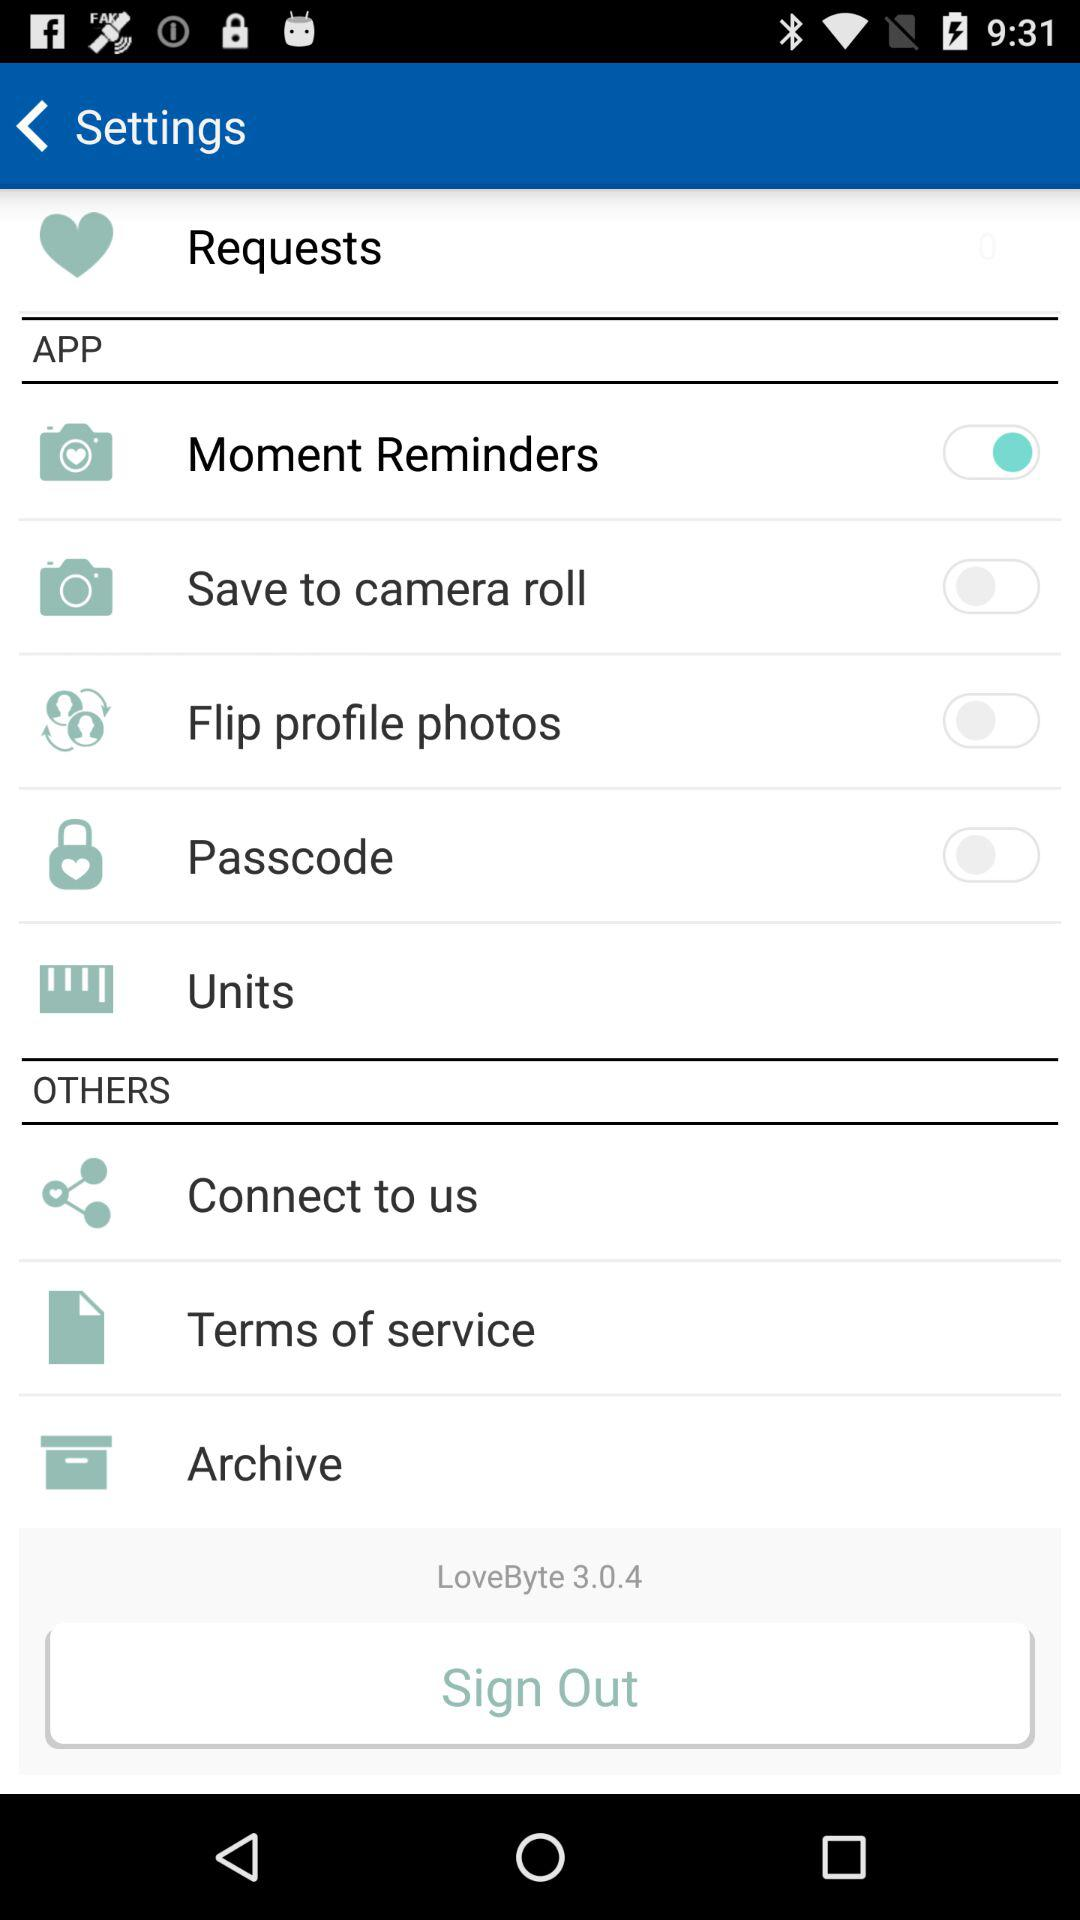How many toggles are there in the settings menu?
Answer the question using a single word or phrase. 4 